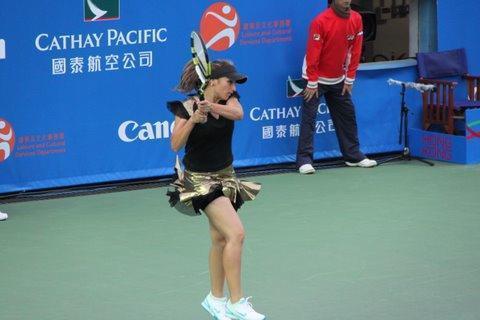How many people are there?
Give a very brief answer. 2. 